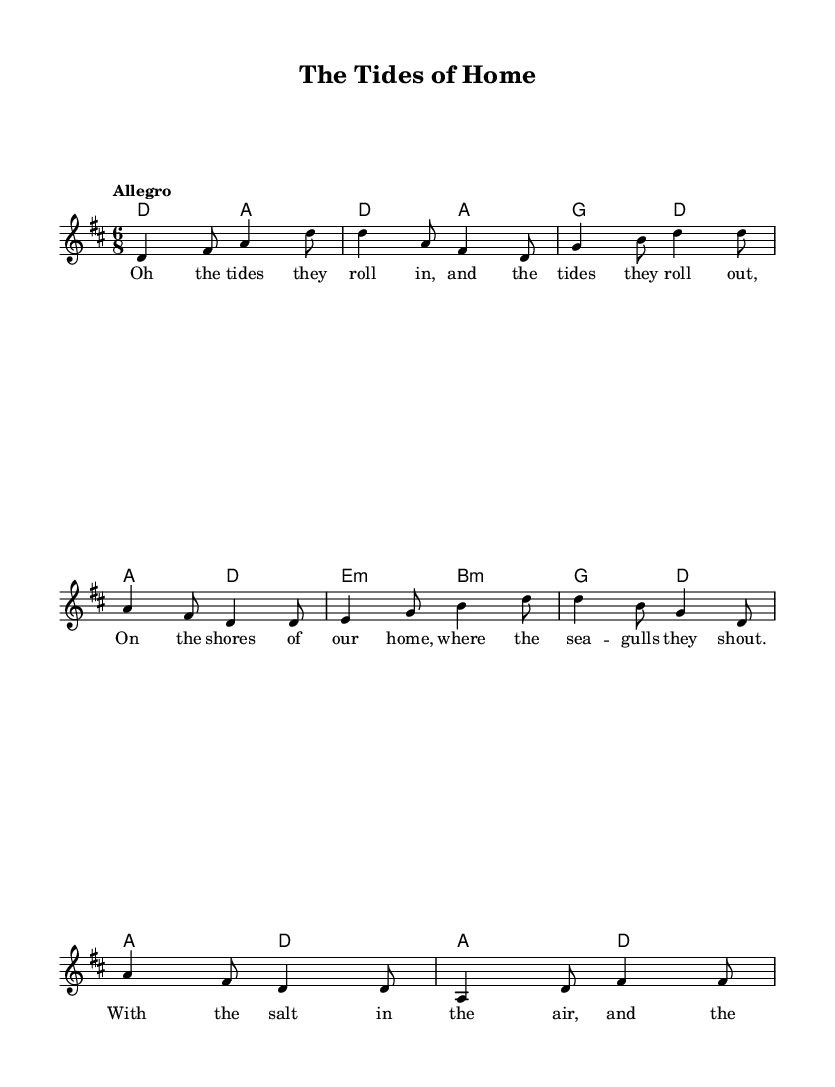What is the key signature of this music? The key signature indicates there are two sharps, F# and C#, which corresponds to the key of D major.
Answer: D major What is the time signature of this music? The time signature is expressed as 6/8, which means there are six eighth notes per measure.
Answer: 6/8 What is the tempo marking for this piece? The tempo marking is "Allegro," which indicates it should be played in a lively and fast manner.
Answer: Allegro How many measures are in the melody section? By counting the distinct groupings in the melody line, there are a total of eight measures in the melody section.
Answer: 8 What is the chord associated with the first measure? The first measure shows a D major chord (represented as D) under the melody, indicating the harmonic structure starts with the tonic chord.
Answer: D Which part of the song contains lyrics? The lyrics are found in the "verse" section, which sit under the melody notes, indicating that this line is meant to be sung.
Answer: verse How does the harmony support the melody? The harmony consists of chords that are primarily diatonic to D major, underscoring the melodic line harmonically and reinforcing the tonal center of the song.
Answer: Diatonic chords 